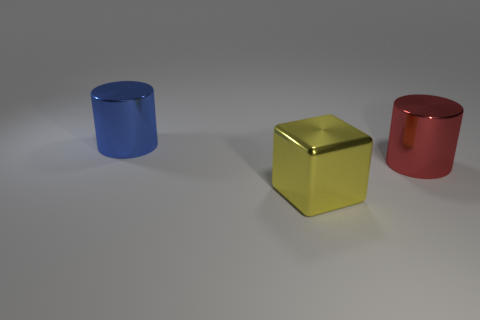Add 2 red metal things. How many objects exist? 5 Subtract all cylinders. How many objects are left? 1 Subtract all yellow shiny blocks. Subtract all large blue shiny cylinders. How many objects are left? 1 Add 2 large yellow shiny blocks. How many large yellow shiny blocks are left? 3 Add 3 large blue cylinders. How many large blue cylinders exist? 4 Subtract 0 yellow balls. How many objects are left? 3 